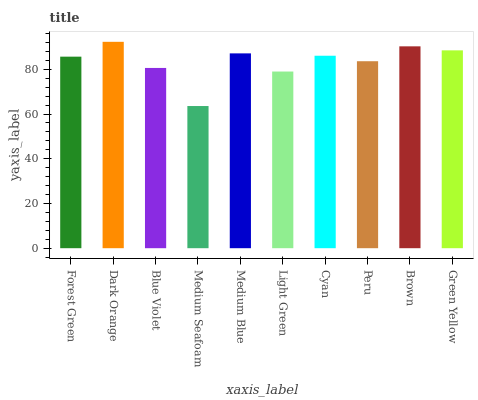Is Blue Violet the minimum?
Answer yes or no. No. Is Blue Violet the maximum?
Answer yes or no. No. Is Dark Orange greater than Blue Violet?
Answer yes or no. Yes. Is Blue Violet less than Dark Orange?
Answer yes or no. Yes. Is Blue Violet greater than Dark Orange?
Answer yes or no. No. Is Dark Orange less than Blue Violet?
Answer yes or no. No. Is Cyan the high median?
Answer yes or no. Yes. Is Forest Green the low median?
Answer yes or no. Yes. Is Brown the high median?
Answer yes or no. No. Is Cyan the low median?
Answer yes or no. No. 